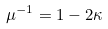<formula> <loc_0><loc_0><loc_500><loc_500>\mu ^ { - 1 } = 1 - 2 \kappa</formula> 